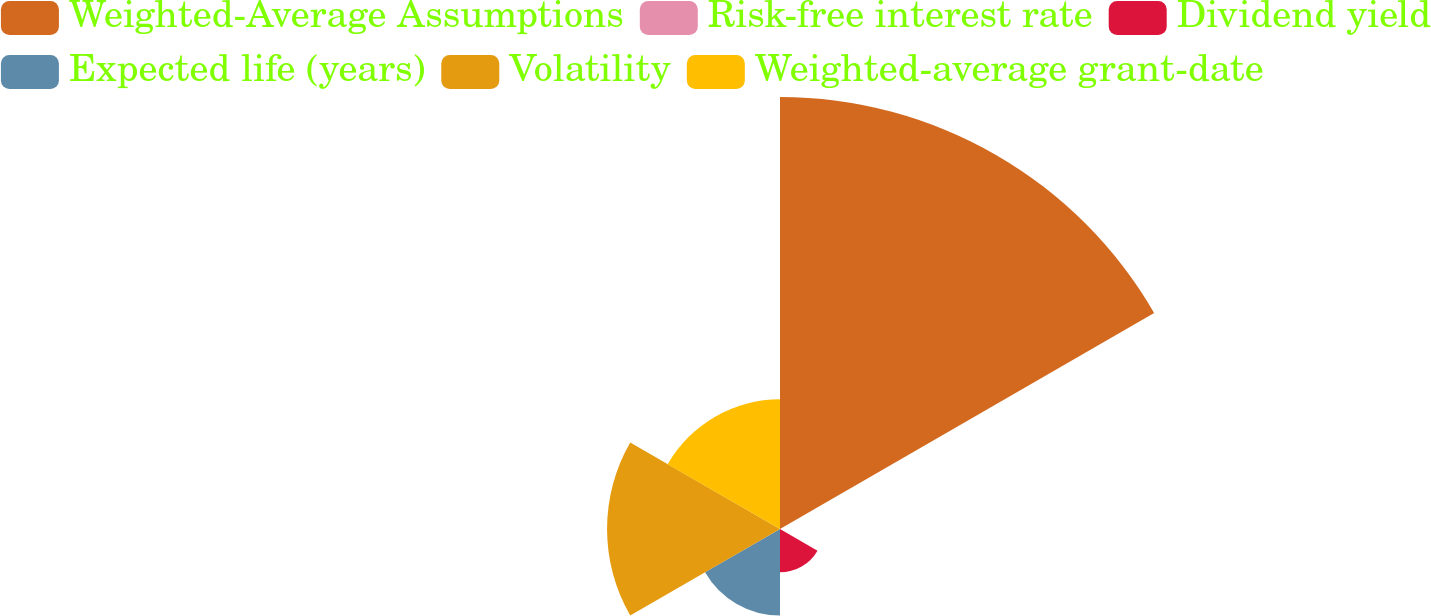<chart> <loc_0><loc_0><loc_500><loc_500><pie_chart><fcel>Weighted-Average Assumptions<fcel>Risk-free interest rate<fcel>Dividend yield<fcel>Expected life (years)<fcel>Volatility<fcel>Weighted-average grant-date<nl><fcel>49.96%<fcel>0.02%<fcel>5.01%<fcel>10.01%<fcel>20.0%<fcel>15.0%<nl></chart> 